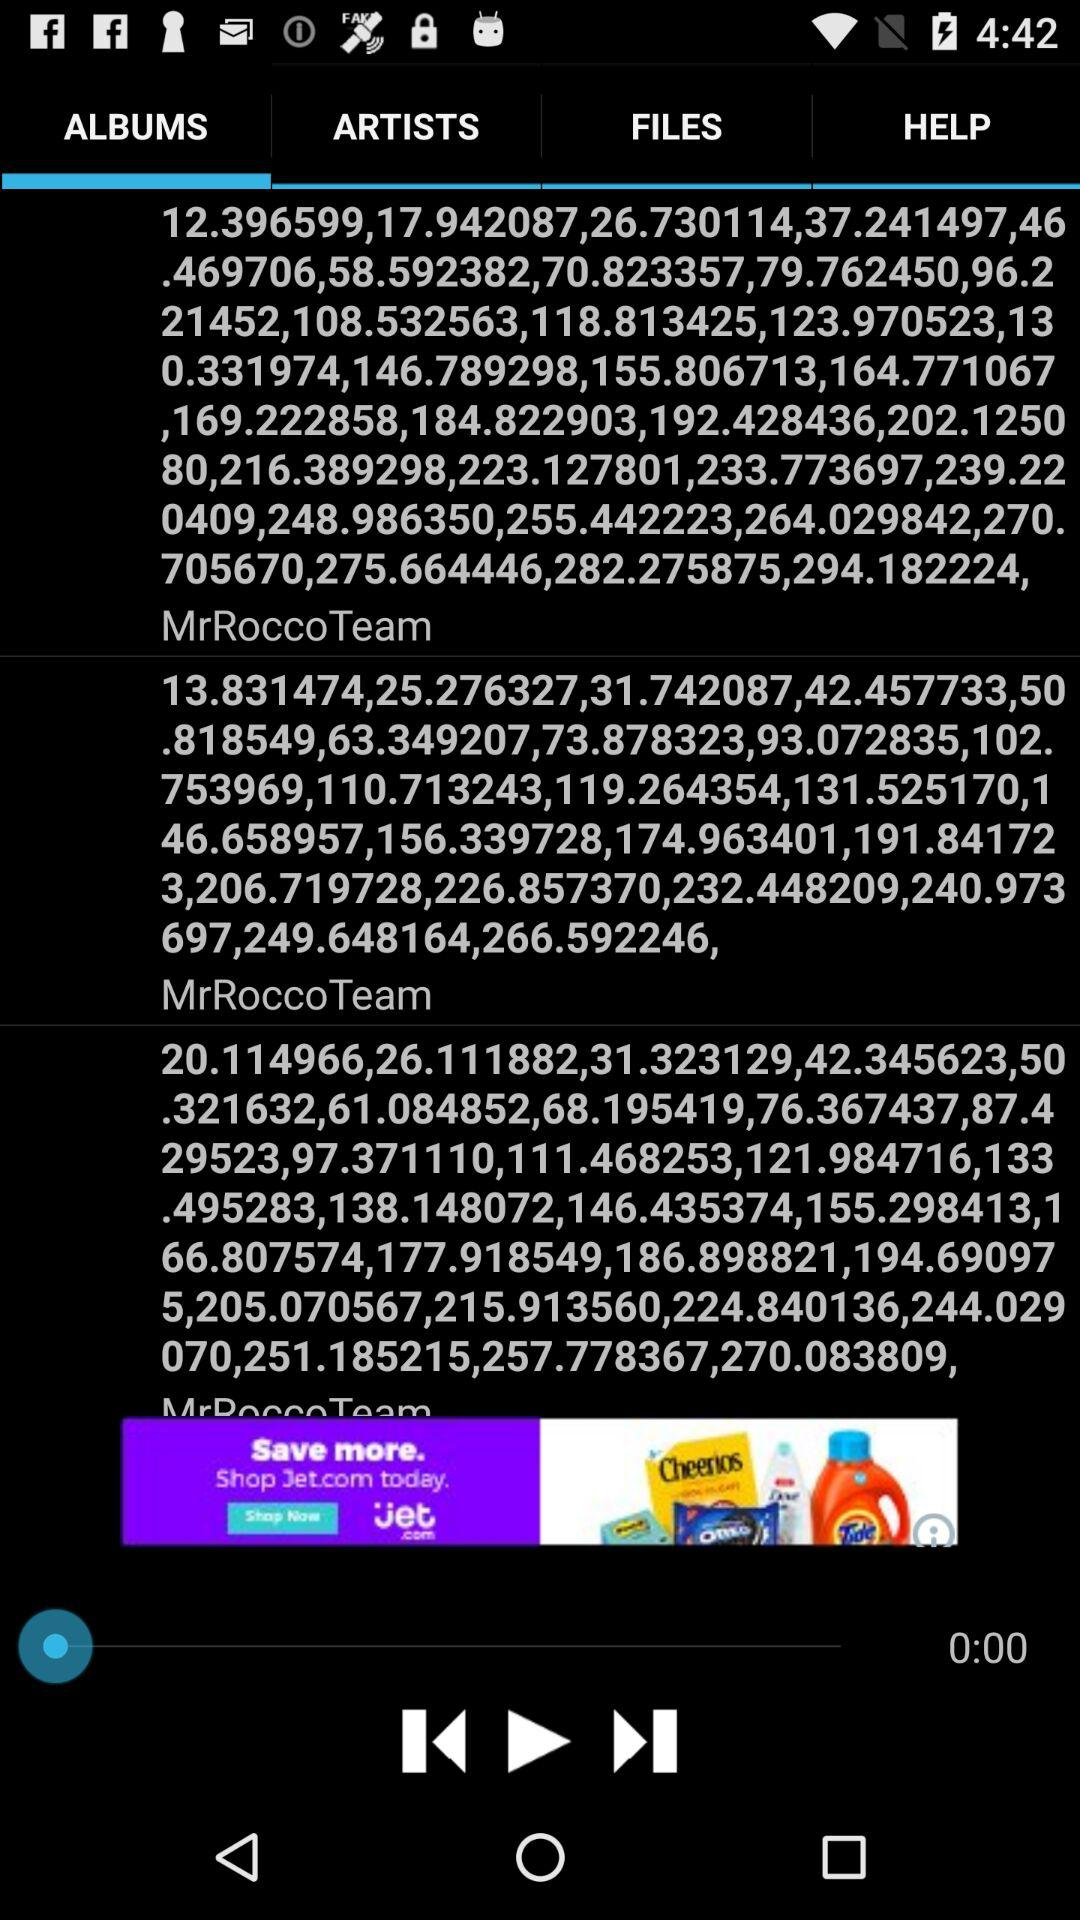Which tab is selected right now? The selected tab is "ALBUMS". 